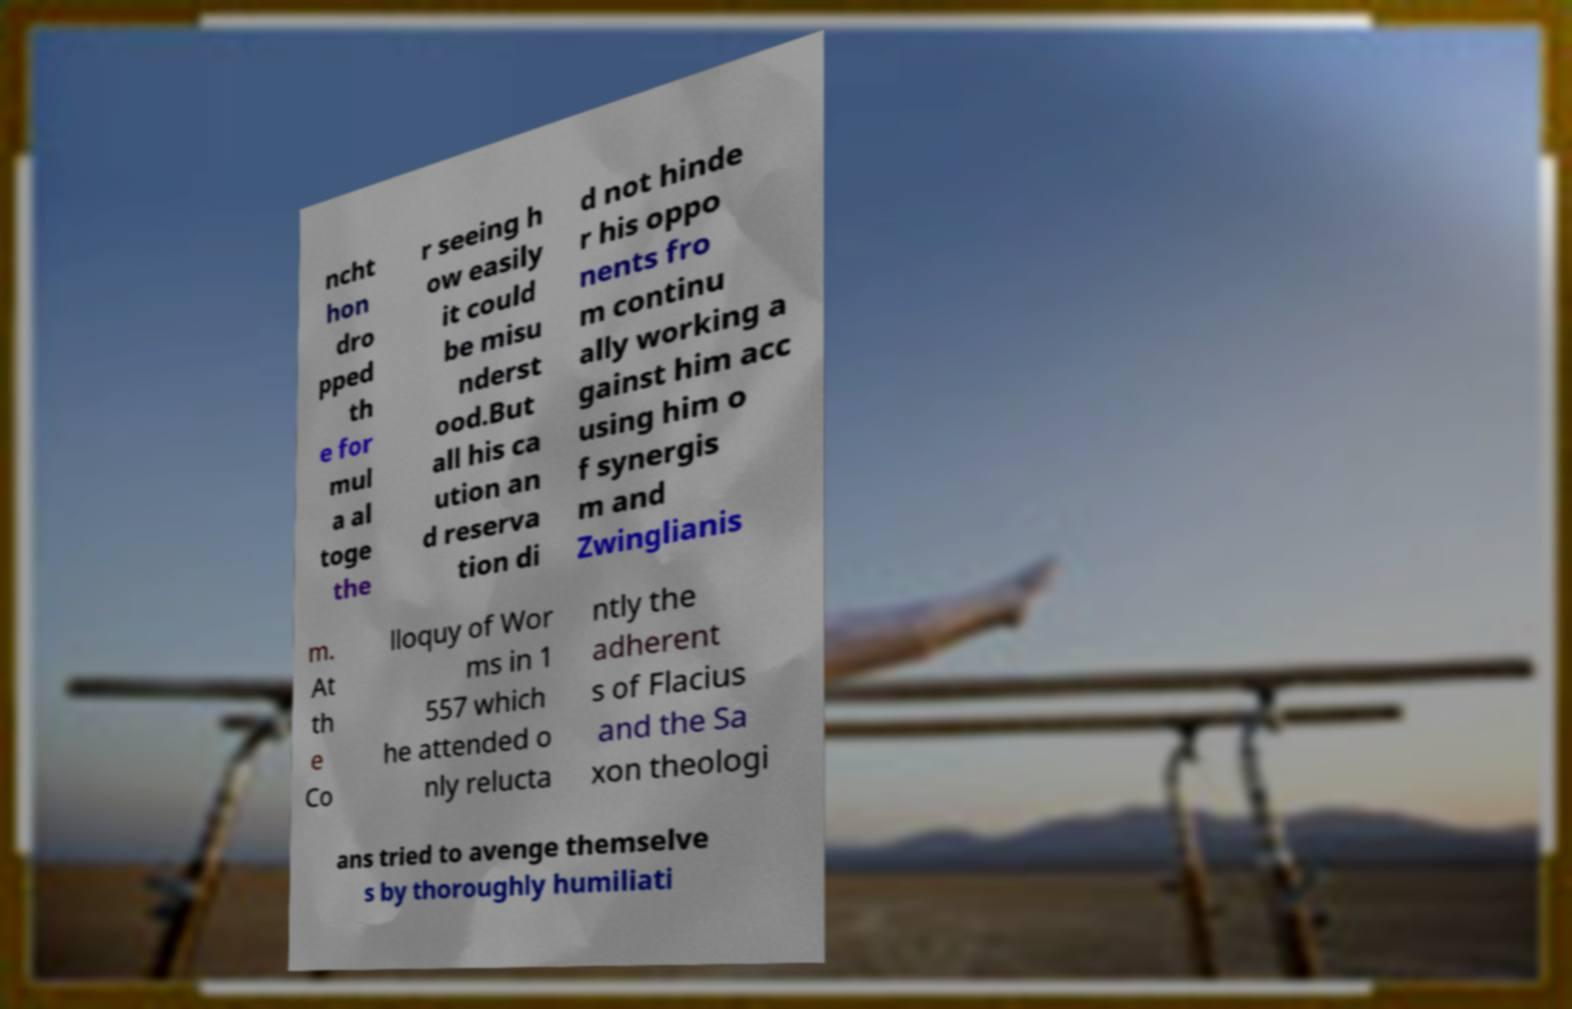Can you accurately transcribe the text from the provided image for me? ncht hon dro pped th e for mul a al toge the r seeing h ow easily it could be misu nderst ood.But all his ca ution an d reserva tion di d not hinde r his oppo nents fro m continu ally working a gainst him acc using him o f synergis m and Zwinglianis m. At th e Co lloquy of Wor ms in 1 557 which he attended o nly relucta ntly the adherent s of Flacius and the Sa xon theologi ans tried to avenge themselve s by thoroughly humiliati 